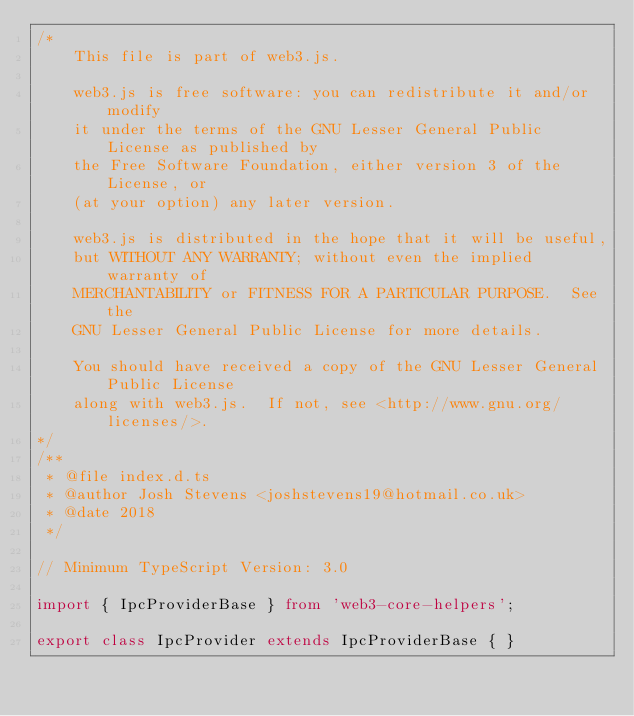Convert code to text. <code><loc_0><loc_0><loc_500><loc_500><_TypeScript_>/*
    This file is part of web3.js.

    web3.js is free software: you can redistribute it and/or modify
    it under the terms of the GNU Lesser General Public License as published by
    the Free Software Foundation, either version 3 of the License, or
    (at your option) any later version.

    web3.js is distributed in the hope that it will be useful,
    but WITHOUT ANY WARRANTY; without even the implied warranty of
    MERCHANTABILITY or FITNESS FOR A PARTICULAR PURPOSE.  See the
    GNU Lesser General Public License for more details.

    You should have received a copy of the GNU Lesser General Public License
    along with web3.js.  If not, see <http://www.gnu.org/licenses/>.
*/
/**
 * @file index.d.ts
 * @author Josh Stevens <joshstevens19@hotmail.co.uk>
 * @date 2018
 */

// Minimum TypeScript Version: 3.0

import { IpcProviderBase } from 'web3-core-helpers';

export class IpcProvider extends IpcProviderBase { }
</code> 